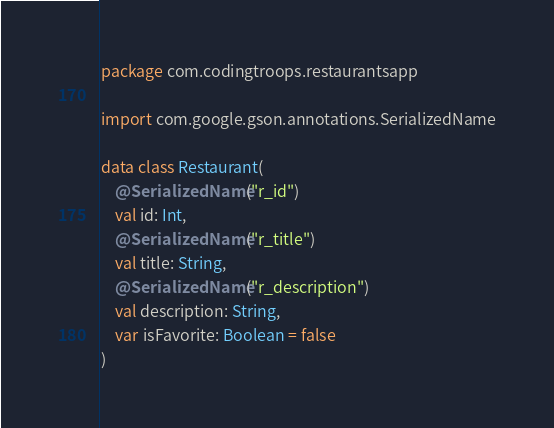<code> <loc_0><loc_0><loc_500><loc_500><_Kotlin_>package com.codingtroops.restaurantsapp

import com.google.gson.annotations.SerializedName

data class Restaurant(
    @SerializedName("r_id")
    val id: Int,
    @SerializedName("r_title")
    val title: String,
    @SerializedName("r_description")
    val description: String,
    var isFavorite: Boolean = false
)</code> 